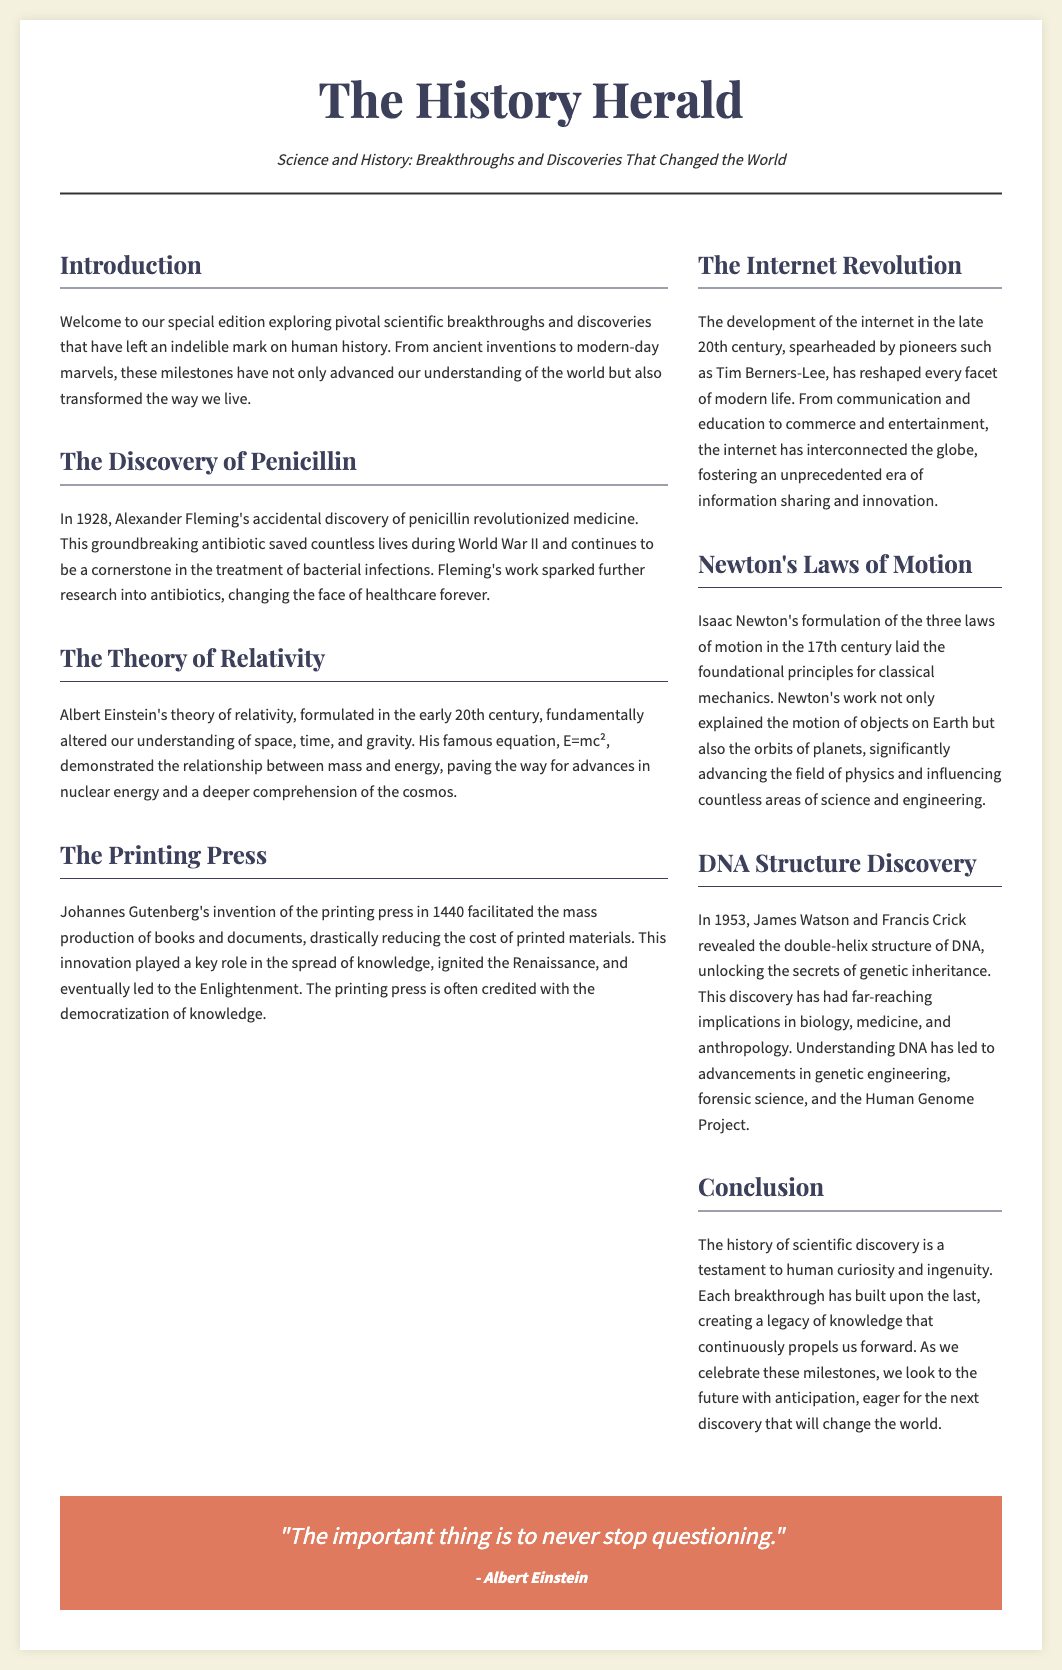What year was penicillin discovered? The document states that penicillin was discovered in 1928 by Alexander Fleming.
Answer: 1928 Who formulated the theory of relativity? The theory of relativity was formulated by Albert Einstein in the early 20th century.
Answer: Albert Einstein What invention is credited with the democratization of knowledge? The printing press, invented by Johannes Gutenberg in 1440, is credited with democratizing knowledge.
Answer: Printing press What are Newton's laws of motion related to? Newton's laws of motion explain the motion of objects on Earth and the orbits of planets.
Answer: Classical mechanics What significant structure did Watson and Crick discover? Watson and Crick discovered the double-helix structure of DNA.
Answer: Double-helix structure What phrase ends the document's quote section? The quote by Albert Einstein ends with "never stop questioning."
Answer: Never stop questioning What is the primary focus of this newspaper layout? The newspaper layout focuses on "Breakthroughs and Discoveries That Changed the World."
Answer: Breakthroughs and Discoveries That Changed the World Which section discusses the role of the internet? The section titled "The Internet Revolution" discusses the role of the internet.
Answer: The Internet Revolution What color is the quote background? The background color of the quote section is a shade of red (#e07a5f).
Answer: Red 